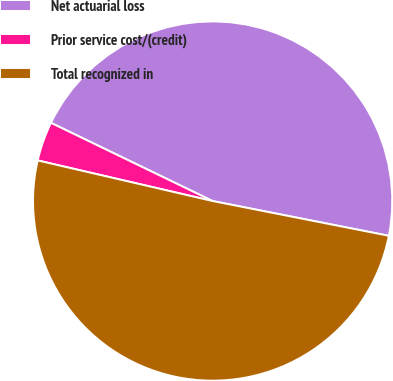Convert chart to OTSL. <chart><loc_0><loc_0><loc_500><loc_500><pie_chart><fcel>Net actuarial loss<fcel>Prior service cost/(credit)<fcel>Total recognized in<nl><fcel>45.93%<fcel>3.54%<fcel>50.53%<nl></chart> 